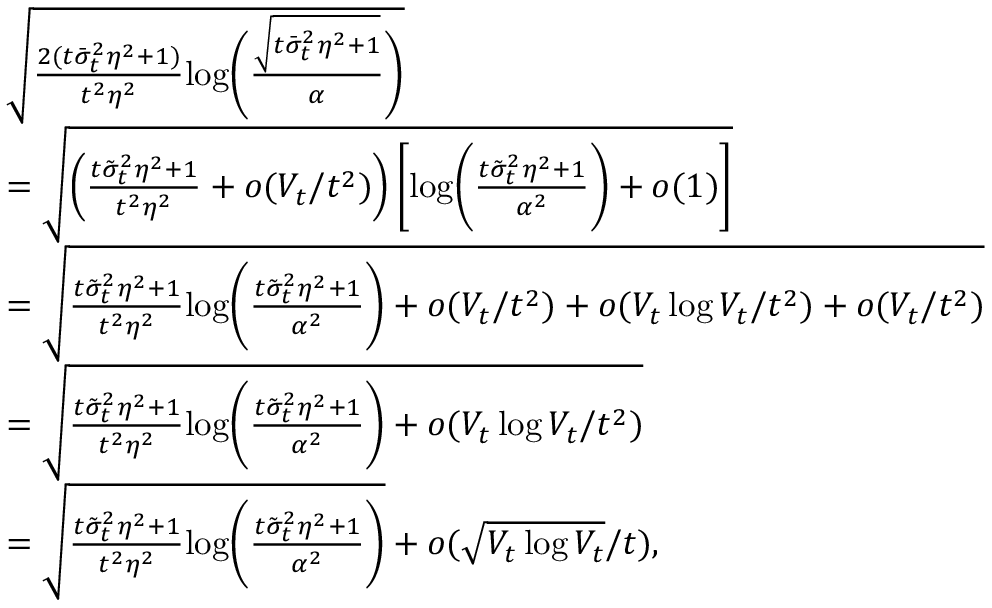Convert formula to latex. <formula><loc_0><loc_0><loc_500><loc_500>\begin{array} { r l } & { \sqrt { \frac { 2 ( t \bar { \sigma } _ { t } ^ { 2 } \eta ^ { 2 } + 1 ) } { t ^ { 2 } \eta ^ { 2 } } \log \left ( \frac { \sqrt { t \bar { \sigma } _ { t } ^ { 2 } \eta ^ { 2 } + 1 } } { \alpha } \right ) } } \\ & { = \sqrt { \left ( \frac { t \tilde { \sigma } _ { t } ^ { 2 } \eta ^ { 2 } + 1 } { t ^ { 2 } \eta ^ { 2 } } + o ( V _ { t } / t ^ { 2 } ) \right ) \left [ \log \left ( \frac { t \tilde { \sigma } _ { t } ^ { 2 } \eta ^ { 2 } + 1 } { \alpha ^ { 2 } } \right ) + o ( 1 ) \right ] } } \\ & { = \sqrt { \frac { t \tilde { \sigma } _ { t } ^ { 2 } \eta ^ { 2 } + 1 } { t ^ { 2 } \eta ^ { 2 } } \log \left ( \frac { t \tilde { \sigma } _ { t } ^ { 2 } \eta ^ { 2 } + 1 } { \alpha ^ { 2 } } \right ) + o ( V _ { t } / t ^ { 2 } ) + o ( V _ { t } \log V _ { t } / t ^ { 2 } ) + o ( V _ { t } / t ^ { 2 } ) } } \\ & { = \sqrt { \frac { t \tilde { \sigma } _ { t } ^ { 2 } \eta ^ { 2 } + 1 } { t ^ { 2 } \eta ^ { 2 } } \log \left ( \frac { t \tilde { \sigma } _ { t } ^ { 2 } \eta ^ { 2 } + 1 } { \alpha ^ { 2 } } \right ) + o ( V _ { t } \log V _ { t } / t ^ { 2 } ) } } \\ & { = \sqrt { \frac { t \tilde { \sigma } _ { t } ^ { 2 } \eta ^ { 2 } + 1 } { t ^ { 2 } \eta ^ { 2 } } \log \left ( \frac { t \tilde { \sigma } _ { t } ^ { 2 } \eta ^ { 2 } + 1 } { \alpha ^ { 2 } } \right ) } + o ( \sqrt { V _ { t } \log V _ { t } } / t ) , } \end{array}</formula> 